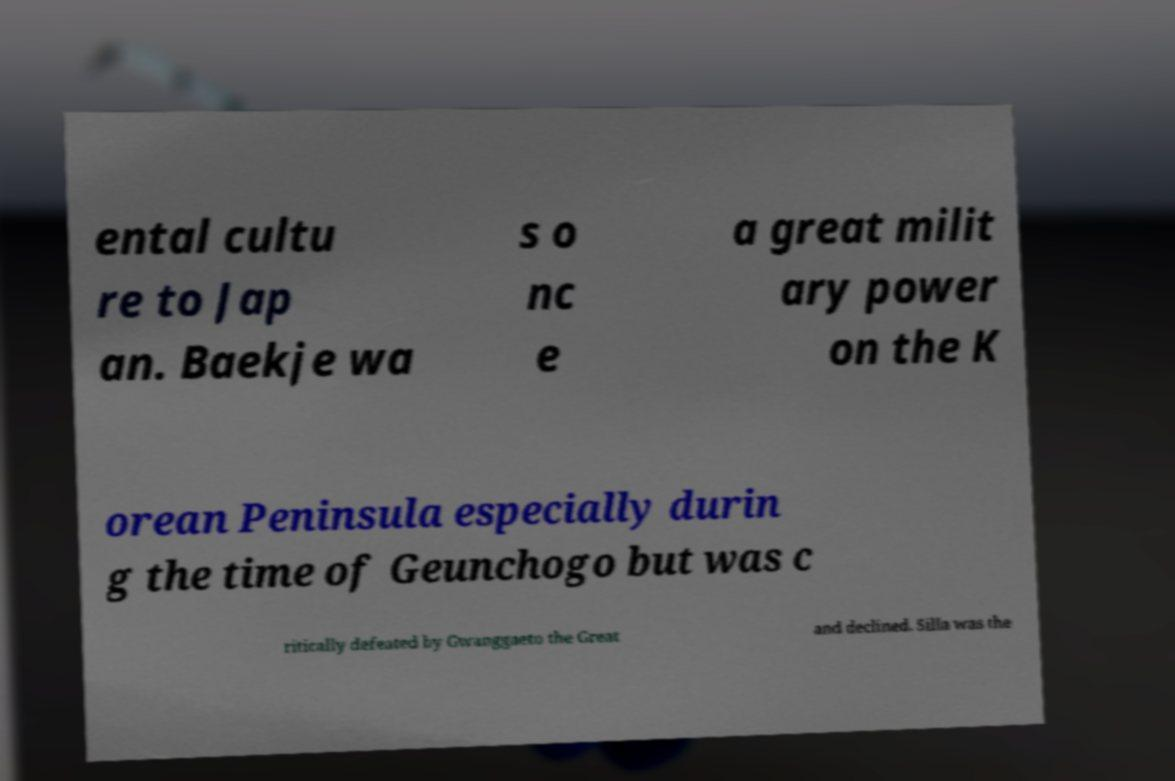Could you extract and type out the text from this image? ental cultu re to Jap an. Baekje wa s o nc e a great milit ary power on the K orean Peninsula especially durin g the time of Geunchogo but was c ritically defeated by Gwanggaeto the Great and declined. Silla was the 